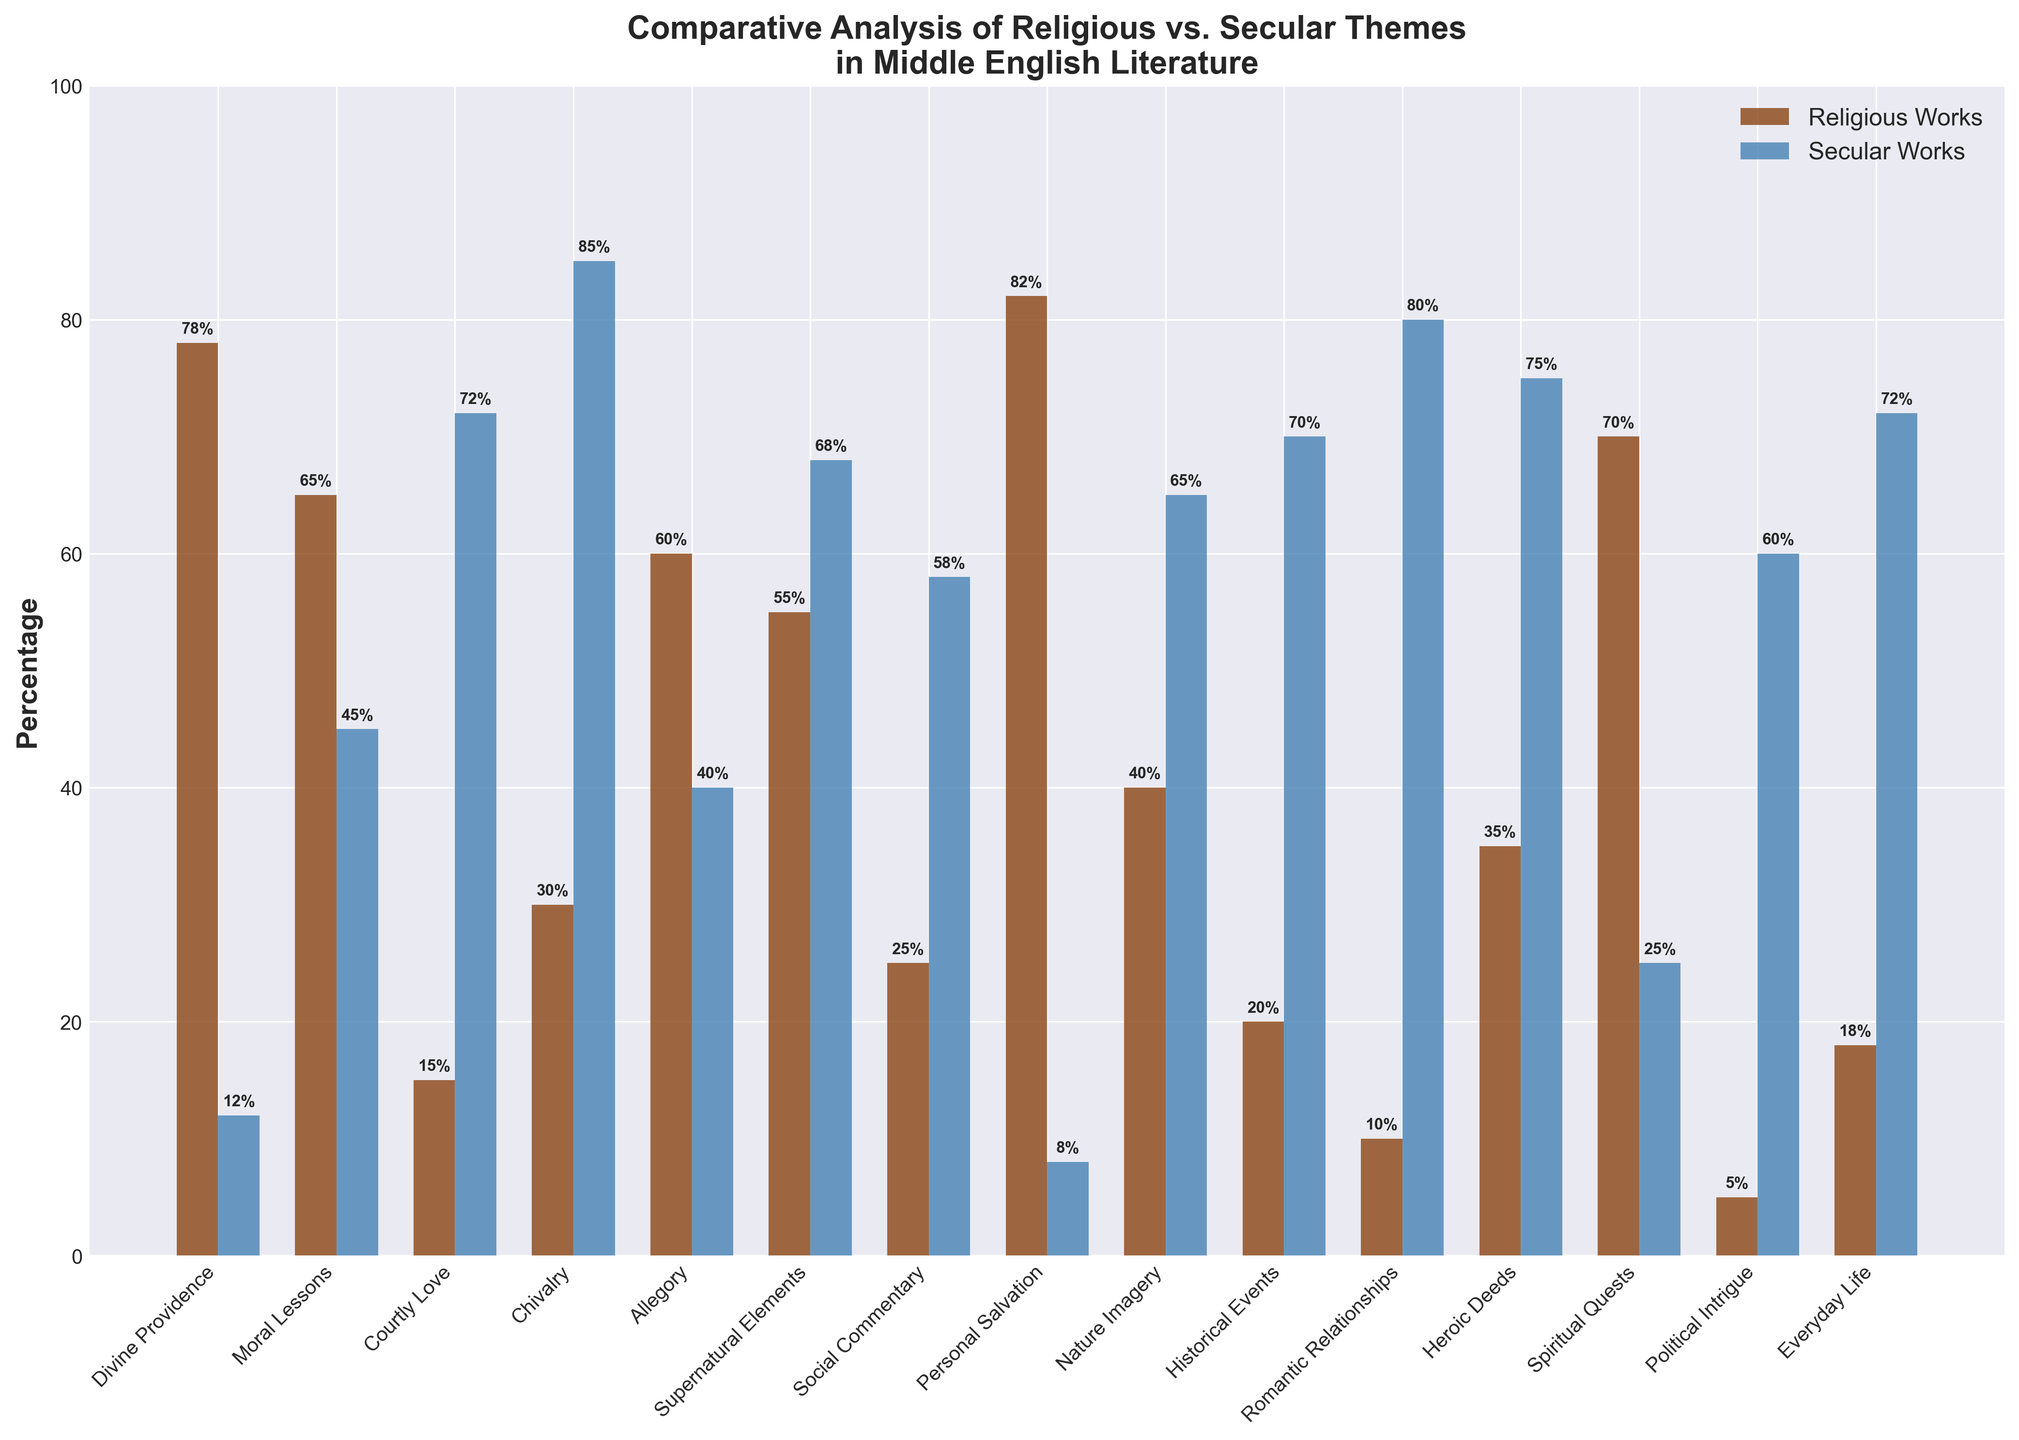Which theme has the highest percentage in religious works? The highest percentage in religious works can be observed by comparing the heights of the brown bars for each theme. The theme with the tallest brown bar is "Personal Salvation" at 82%.
Answer: Personal Salvation Which theme has the highest percentage in secular works? The highest percentage in secular works can be observed by comparing the heights of the blue bars for each theme. The theme with the tallest blue bar is "Chivalry" at 85%.
Answer: Chivalry Which theme is equally prominent in both religious and secular works? To find a theme that is equally prominent in both types of works, look for bars of similar height for both colors. The closest match here is "Moral Lessons" with 65% in religious and 45% in secular works.
Answer: None What is the difference in percentage between religious and secular works for "Courtly Love"? Determine the percentage for both types of works and subtract the smaller from the larger. For "Courtly Love", secular works are at 72% and religious works are at 15%, so the difference is 72 - 15 = 57%.
Answer: 57% What is the average percentage of "Allegory" in both religious and secular works? Add the percentages for religious and secular works for "Allegory" and divide by 2. Specifically, (60% + 40%) / 2 = 50%.
Answer: 50% Among the themes "Historical Events", "Romantic Relationships", and "Heroic Deeds", which one has the lowest percentage in religious works? Compare the heights of the brown bars for these themes. "Historical Events" has the lowest percentage at 20%, lower than "Romantic Relationships" at 10% and "Heroic Deeds" at 35%.
Answer: Romantic Relationships For which theme is the sum of percentages of religious and secular works closest to 100%? Calculate the sum for each theme and check which one is closest to 100%. "Supernatural Elements" sums to 55% + 68% = 123%, "Secular" sums to 15% + 72% = 87%, among others, find the closest. "Chivalry" sums to 30% + 85% = 115%
Answer: Nature Imagery How does the percentage of "Social Commentary" in secular works compare to religious works? Compare the heights of the blue and brown bars for "Social Commentary". The percentage for secular works is significantly higher at 58% compared to 25% in religious works.
Answer: Secular works > Religious works What themes have a higher percentage in religious works compared to secular works? Compare the heights of the brown bars relative to the blue bars for each theme and identify the ones where the brown bars are taller. The themes are "Divine Providence", "Moral Lessons", "Allegory", "Personal Salvation", and "Spiritual Quests".
Answer: Divine Providence, Moral Lessons, Allegory, Personal Salvation, Spiritual Quests 